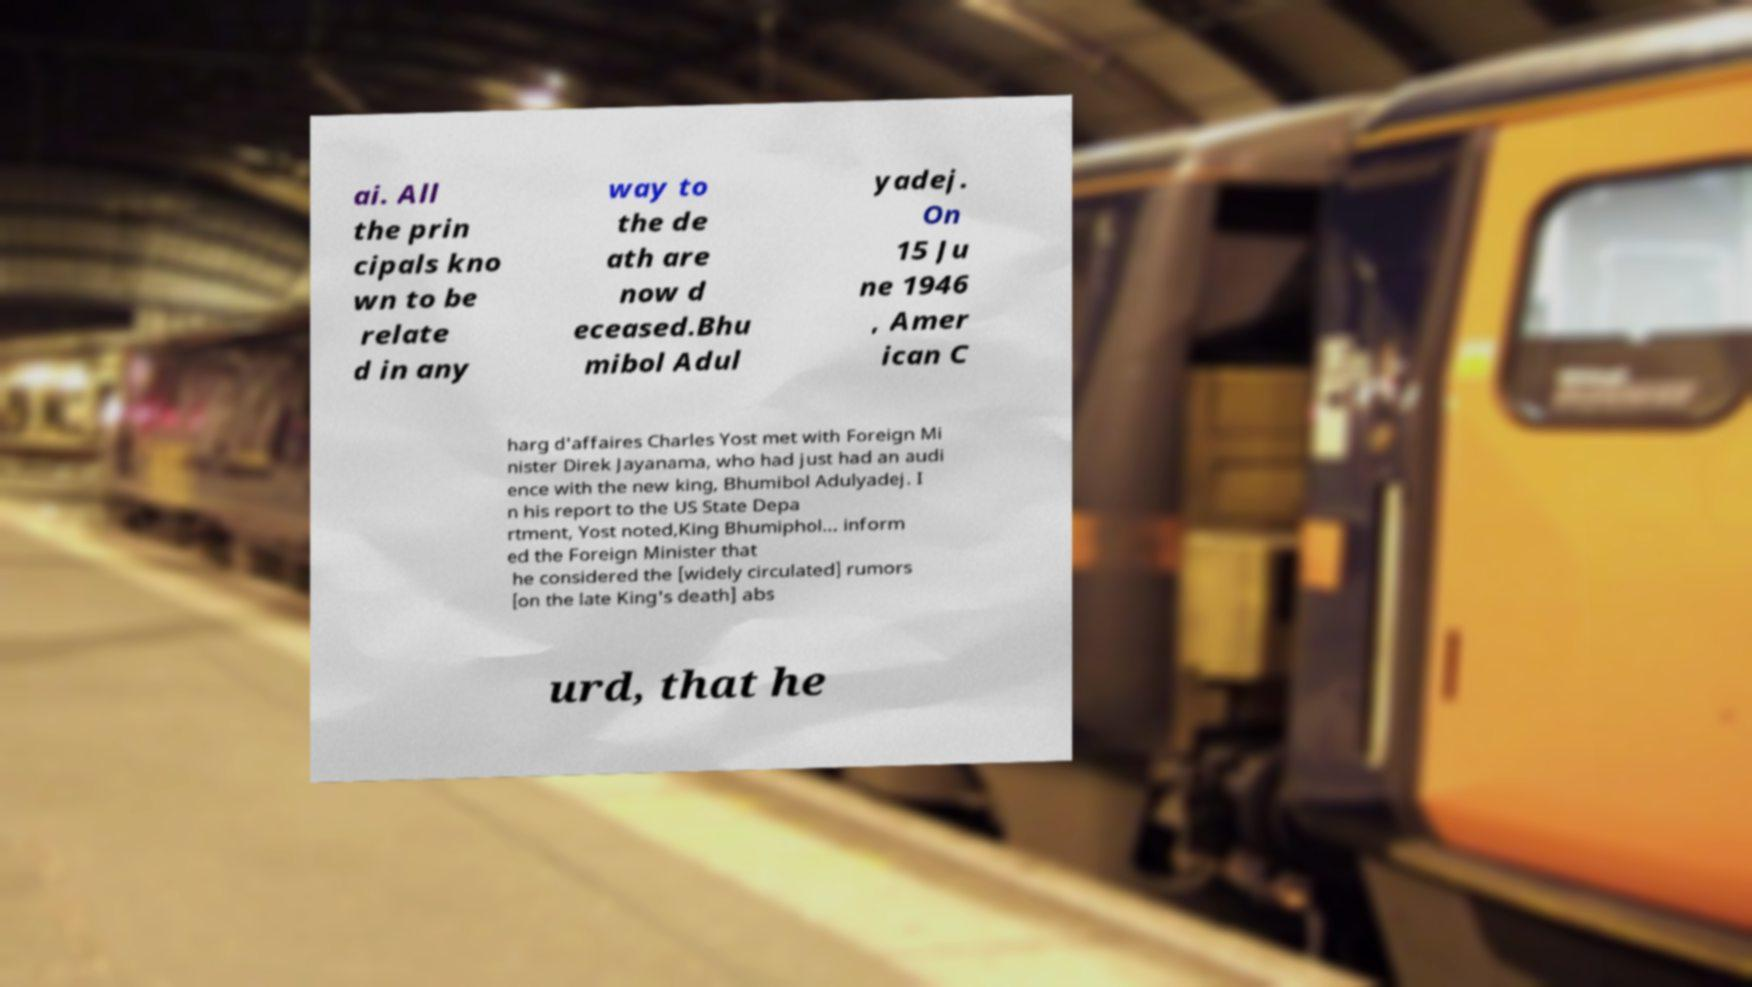Please read and relay the text visible in this image. What does it say? ai. All the prin cipals kno wn to be relate d in any way to the de ath are now d eceased.Bhu mibol Adul yadej. On 15 Ju ne 1946 , Amer ican C harg d'affaires Charles Yost met with Foreign Mi nister Direk Jayanama, who had just had an audi ence with the new king, Bhumibol Adulyadej. I n his report to the US State Depa rtment, Yost noted,King Bhumiphol... inform ed the Foreign Minister that he considered the [widely circulated] rumors [on the late King's death] abs urd, that he 